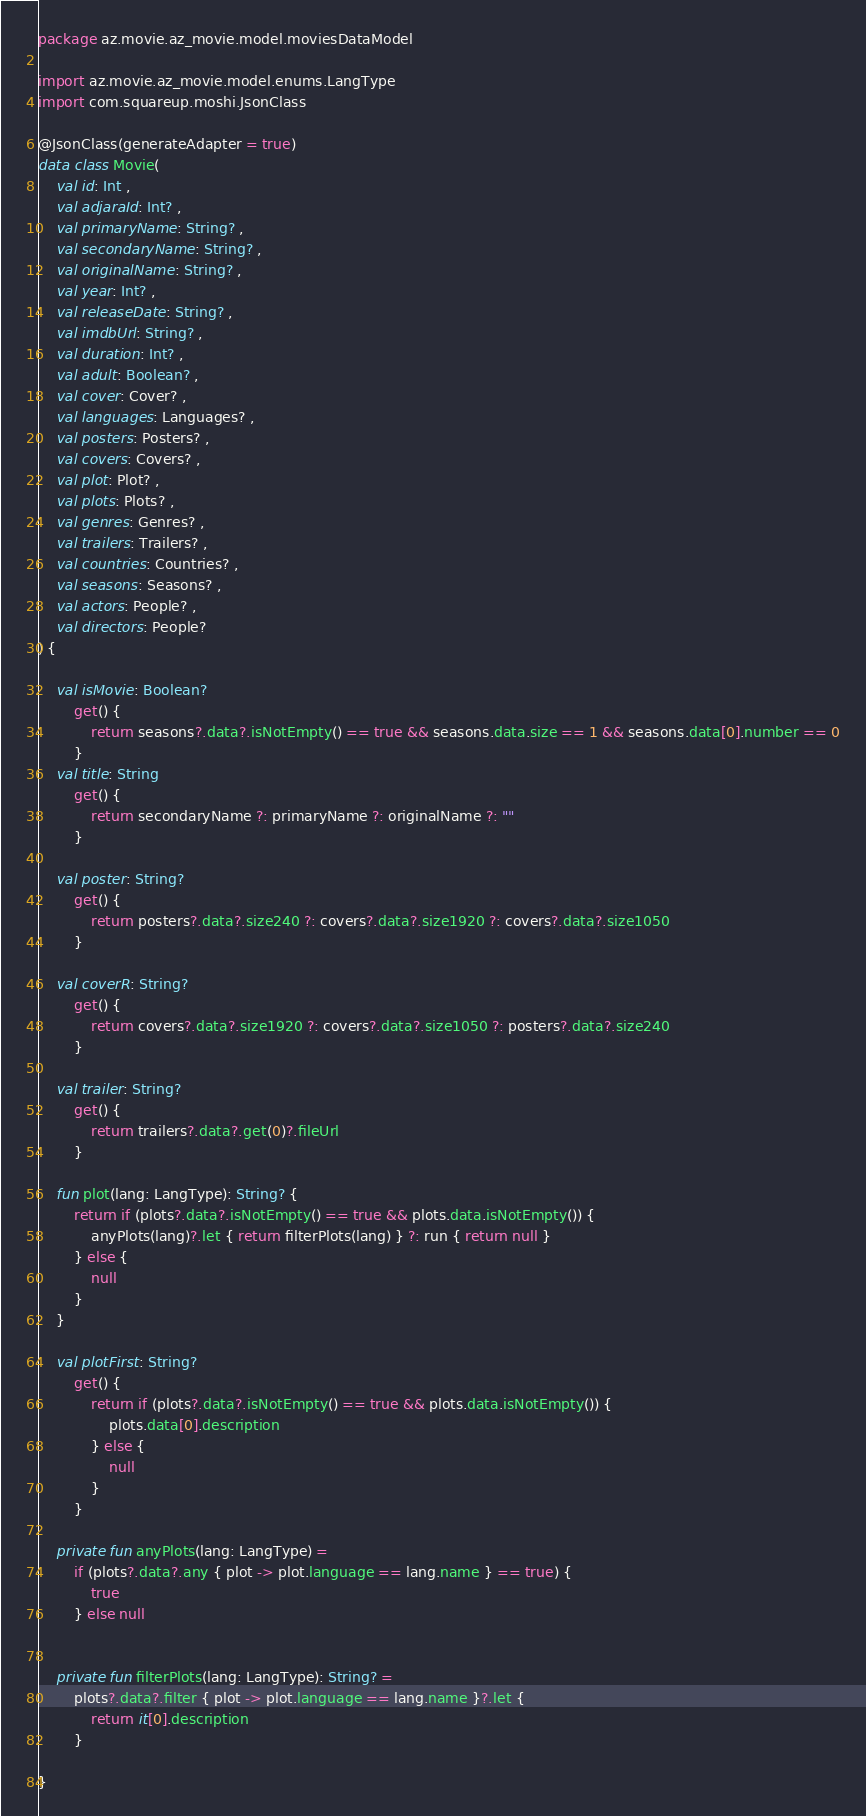<code> <loc_0><loc_0><loc_500><loc_500><_Kotlin_>package az.movie.az_movie.model.moviesDataModel

import az.movie.az_movie.model.enums.LangType
import com.squareup.moshi.JsonClass

@JsonClass(generateAdapter = true)
data class Movie(
    val id: Int ,
    val adjaraId: Int? ,
    val primaryName: String? ,
    val secondaryName: String? ,
    val originalName: String? ,
    val year: Int? ,
    val releaseDate: String? ,
    val imdbUrl: String? ,
    val duration: Int? ,
    val adult: Boolean? ,
    val cover: Cover? ,
    val languages: Languages? ,
    val posters: Posters? ,
    val covers: Covers? ,
    val plot: Plot? ,
    val plots: Plots? ,
    val genres: Genres? ,
    val trailers: Trailers? ,
    val countries: Countries? ,
    val seasons: Seasons? ,
    val actors: People? ,
    val directors: People?
) {

    val isMovie: Boolean?
        get() {
            return seasons?.data?.isNotEmpty() == true && seasons.data.size == 1 && seasons.data[0].number == 0
        }
    val title: String
        get() {
            return secondaryName ?: primaryName ?: originalName ?: ""
        }

    val poster: String?
        get() {
            return posters?.data?.size240 ?: covers?.data?.size1920 ?: covers?.data?.size1050
        }

    val coverR: String?
        get() {
            return covers?.data?.size1920 ?: covers?.data?.size1050 ?: posters?.data?.size240
        }

    val trailer: String?
        get() {
            return trailers?.data?.get(0)?.fileUrl
        }

    fun plot(lang: LangType): String? {
        return if (plots?.data?.isNotEmpty() == true && plots.data.isNotEmpty()) {
            anyPlots(lang)?.let { return filterPlots(lang) } ?: run { return null }
        } else {
            null
        }
    }

    val plotFirst: String?
        get() {
            return if (plots?.data?.isNotEmpty() == true && plots.data.isNotEmpty()) {
                plots.data[0].description
            } else {
                null
            }
        }

    private fun anyPlots(lang: LangType) =
        if (plots?.data?.any { plot -> plot.language == lang.name } == true) {
            true
        } else null


    private fun filterPlots(lang: LangType): String? =
        plots?.data?.filter { plot -> plot.language == lang.name }?.let {
            return it[0].description
        }

}


</code> 